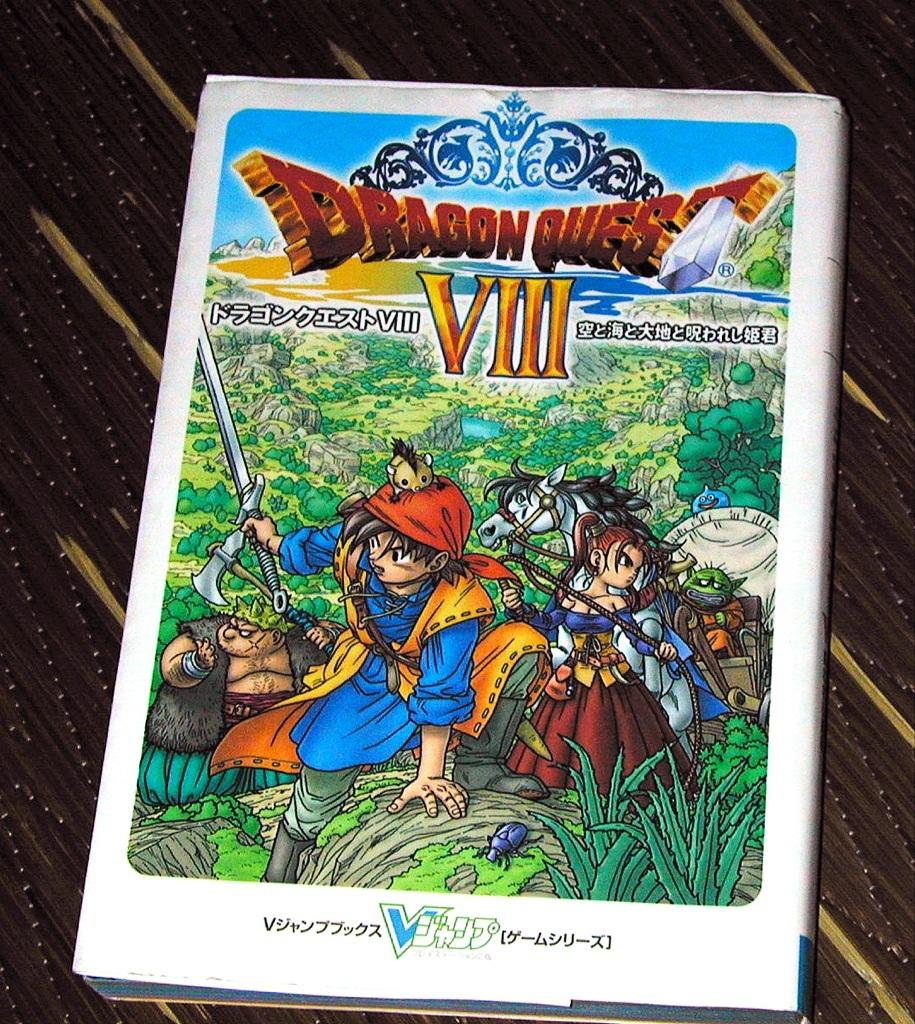What is present in the image that contains images and text? There is a poster in the image that contains images and text. What is the poster attached to or placed on? The poster is on an object. What is the condition of the toothbrush in the image? There is no toothbrush present in the image. How does the poster affect the stomach in the image? The poster does not have any direct effect on the stomach; it is a visual object containing images and text. 